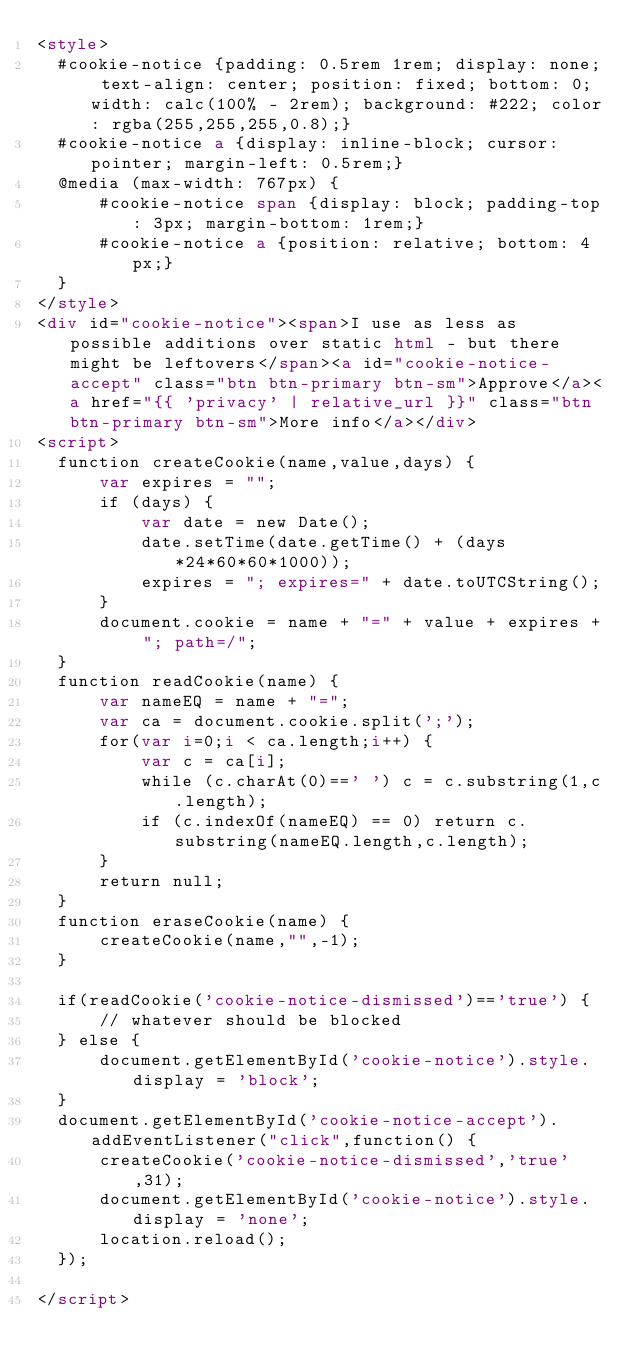Convert code to text. <code><loc_0><loc_0><loc_500><loc_500><_HTML_><style>
  #cookie-notice {padding: 0.5rem 1rem; display: none; text-align: center; position: fixed; bottom: 0; width: calc(100% - 2rem); background: #222; color: rgba(255,255,255,0.8);}
  #cookie-notice a {display: inline-block; cursor: pointer; margin-left: 0.5rem;}
  @media (max-width: 767px) {
      #cookie-notice span {display: block; padding-top: 3px; margin-bottom: 1rem;}
      #cookie-notice a {position: relative; bottom: 4px;}
  }
</style>
<div id="cookie-notice"><span>I use as less as possible additions over static html - but there might be leftovers</span><a id="cookie-notice-accept" class="btn btn-primary btn-sm">Approve</a><a href="{{ 'privacy' | relative_url }}" class="btn btn-primary btn-sm">More info</a></div>
<script>
  function createCookie(name,value,days) {
      var expires = "";
      if (days) {
          var date = new Date();
          date.setTime(date.getTime() + (days*24*60*60*1000));
          expires = "; expires=" + date.toUTCString();
      }
      document.cookie = name + "=" + value + expires + "; path=/";
  }
  function readCookie(name) {
      var nameEQ = name + "=";
      var ca = document.cookie.split(';');
      for(var i=0;i < ca.length;i++) {
          var c = ca[i];
          while (c.charAt(0)==' ') c = c.substring(1,c.length);
          if (c.indexOf(nameEQ) == 0) return c.substring(nameEQ.length,c.length);
      }
      return null;
  }
  function eraseCookie(name) {
      createCookie(name,"",-1);
  }

  if(readCookie('cookie-notice-dismissed')=='true') {
      // whatever should be blocked
  } else {
      document.getElementById('cookie-notice').style.display = 'block';
  }
  document.getElementById('cookie-notice-accept').addEventListener("click",function() {
      createCookie('cookie-notice-dismissed','true',31);
      document.getElementById('cookie-notice').style.display = 'none';
      location.reload();
  });

</script></code> 